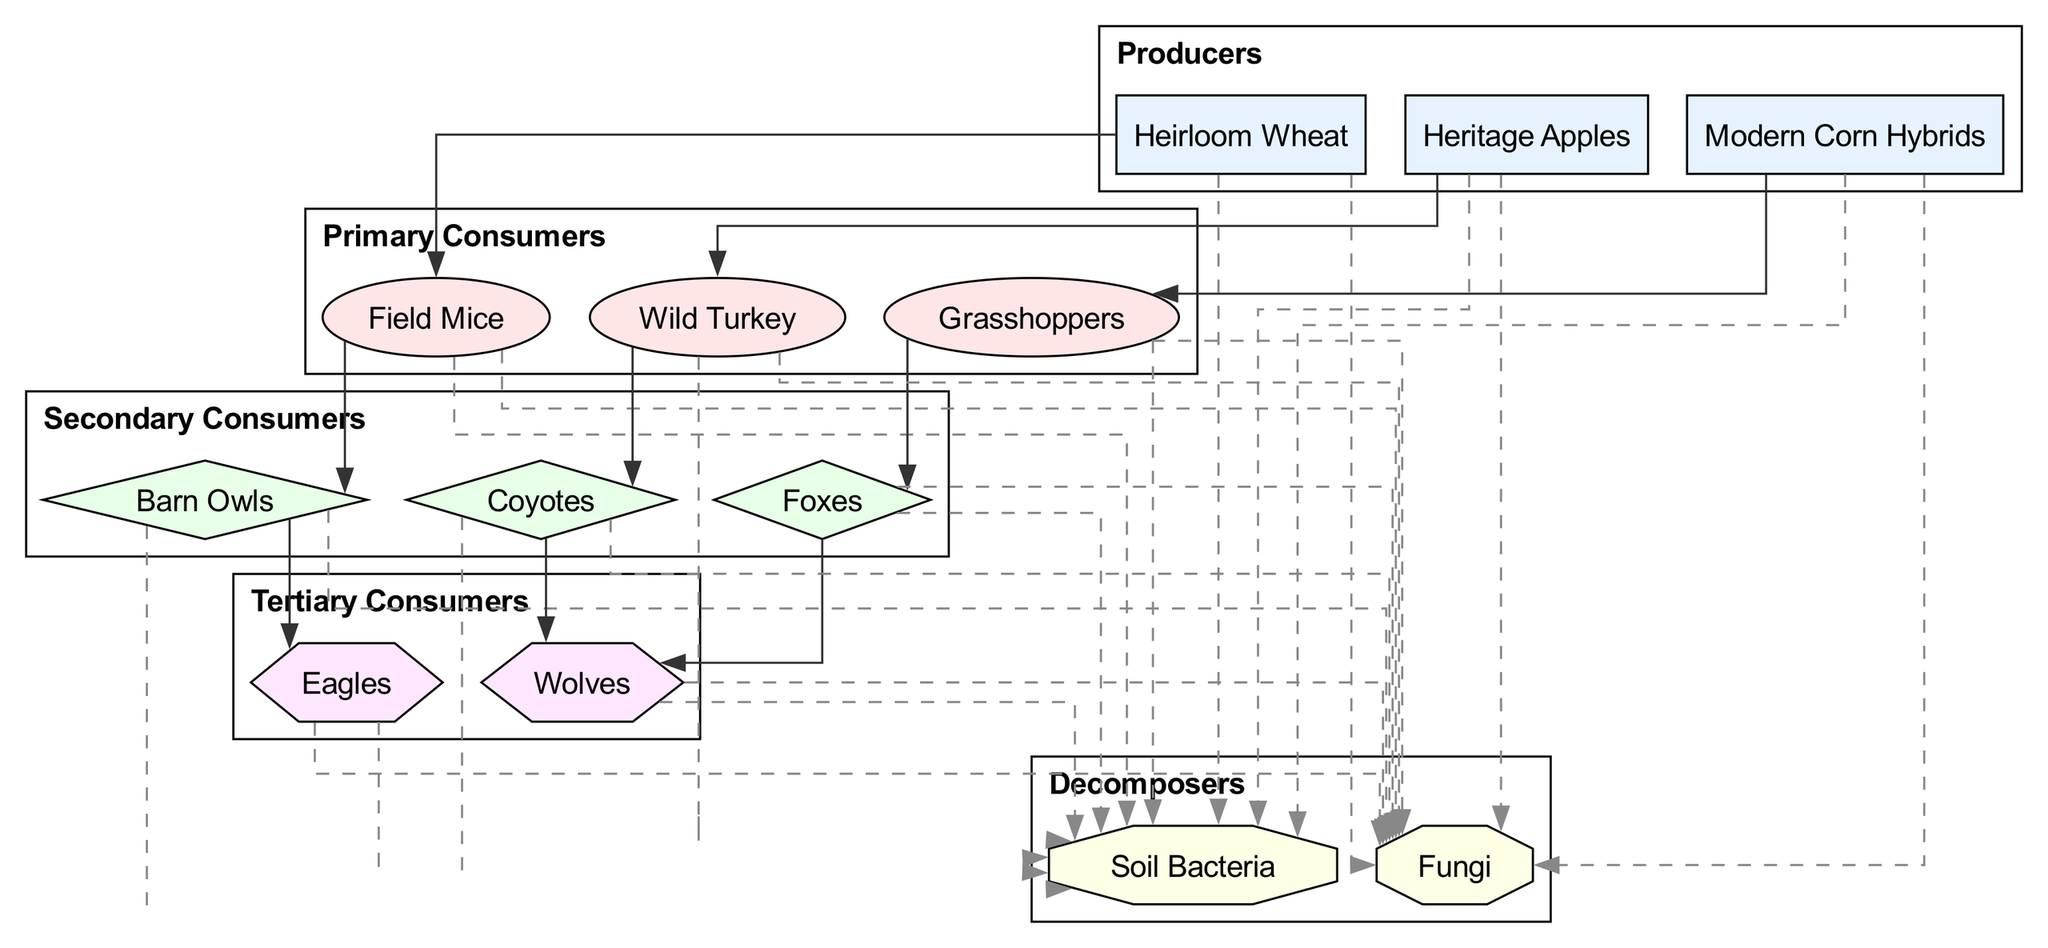What are the primary producers listed in the diagram? The diagram identifies three primary producers: Heirloom Wheat, Heritage Apples, and Modern Corn Hybrids. These are shown at the top of the food chain.
Answer: Heirloom Wheat, Heritage Apples, Modern Corn Hybrids How many primary consumers are there? There are three primary consumers in the diagram: Field Mice, Grasshoppers, and Wild Turkey. This information is derived from counting the nodes in the primary consumers section of the diagram.
Answer: 3 Which primary consumer is linked to Barn Owls? The diagram shows that Field Mice are the primary consumers linked to Barn Owls, as indicated by the connection arrow between them.
Answer: Field Mice What is the relationship between Heritage Apples and Coyotes? There is no direct relationship between Heritage Apples and Coyotes in the diagram; instead, Heritage Apples connect to Wild Turkey, and Wild Turkey connects to Coyotes.
Answer: None Which secondary consumer consumes Grasshoppers? The diagram indicates that Foxes consume Grasshoppers, as indicated by the connection relationship shown through a directed edge from Grasshoppers to Foxes.
Answer: Foxes How many connections are there in total in the food chain? The total number of connections is ten, calculated by counting each arrow or relationship between the nodes throughout the entire diagram.
Answer: 10 Which top-level consumer is indirectly connected to Modern Corn Hybrids? Eagles are the top-level consumers indirectly connected to Modern Corn Hybrids, as they are linked through Barn Owls, which consume Field Mice.
Answer: Eagles What role do Soil Bacteria play in the food chain? Soil Bacteria are decomposers in this food chain, indicated by the direct connection from all organisms in the chain to Soil Bacteria, reinforcing their role in breaking down organic matter.
Answer: Decomposers Which tertiary consumer is eaten by Wolves? The diagram illustrates that Coyotes are eaten by Wolves, indicating that Coyotes serve as a direct connection to the tertiary consumers.
Answer: Coyotes 